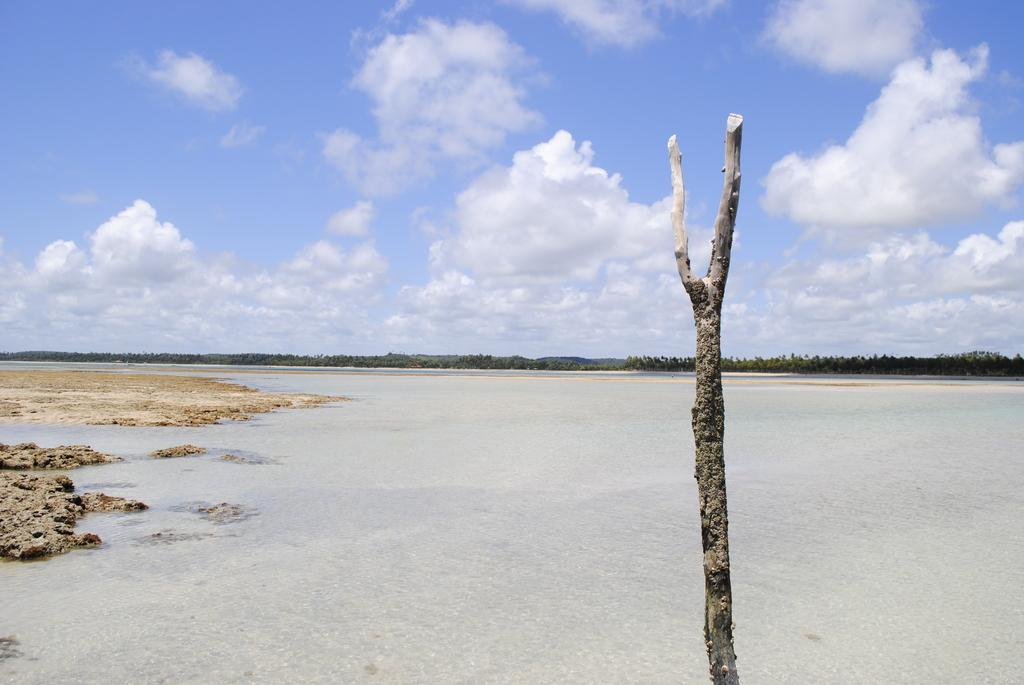What type of object can be seen in the image made of wood? There is a wooden branch in the image. What natural element is visible in the image? Water is visible in the image. What type of vegetation can be seen in the image? Trees are present in the image. What is visible in the background of the image? The sky is visible in the image. What can be observed in the sky in the image? Clouds are present in the sky. Where are the chickens playing volleyball in the image? There are no chickens or volleyball present in the image. What type of ring can be seen in the image? There is no ring present in the image. 